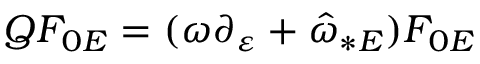<formula> <loc_0><loc_0><loc_500><loc_500>Q F _ { 0 E } = ( \omega \partial _ { \varepsilon } + { \hat { \omega } } _ { \ast E } ) F _ { 0 E }</formula> 